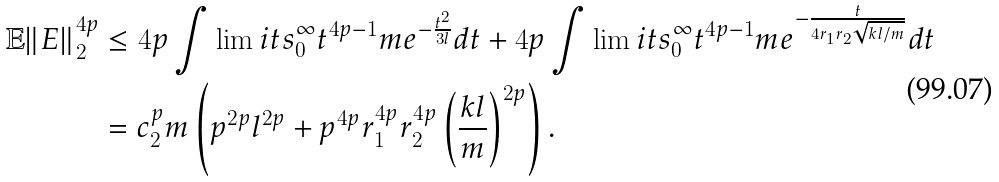<formula> <loc_0><loc_0><loc_500><loc_500>\mathbb { E } \| E \| _ { 2 } ^ { 4 p } & \leq 4 p \int \lim i t s _ { 0 } ^ { \infty } t ^ { 4 p - 1 } m e ^ { - \frac { t ^ { 2 } } { 3 l } } d t + 4 p \int \lim i t s _ { 0 } ^ { \infty } t ^ { 4 p - 1 } m e ^ { - \frac { t } { 4 r _ { 1 } r _ { 2 } \sqrt { k l / m } } } d t \\ & = c _ { 2 } ^ { p } m \left ( p ^ { 2 p } l ^ { 2 p } + p ^ { 4 p } r _ { 1 } ^ { 4 p } r _ { 2 } ^ { 4 p } \left ( \frac { k l } { m } \right ) ^ { 2 p } \right ) .</formula> 